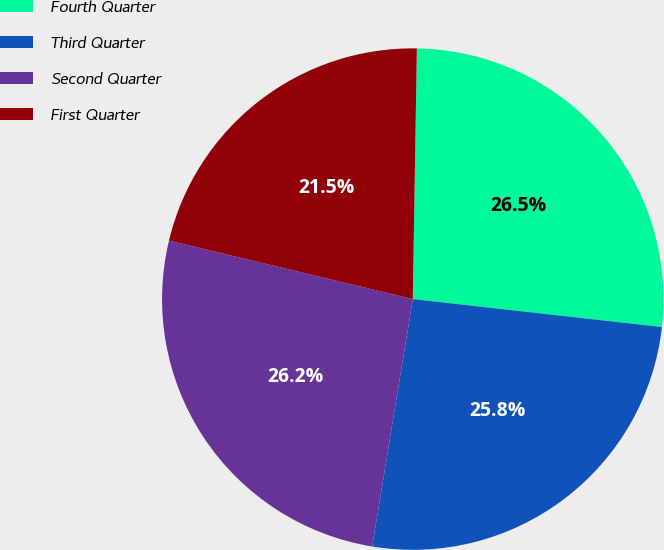Convert chart. <chart><loc_0><loc_0><loc_500><loc_500><pie_chart><fcel>Fourth Quarter<fcel>Third Quarter<fcel>Second Quarter<fcel>First Quarter<nl><fcel>26.52%<fcel>25.81%<fcel>26.16%<fcel>21.51%<nl></chart> 